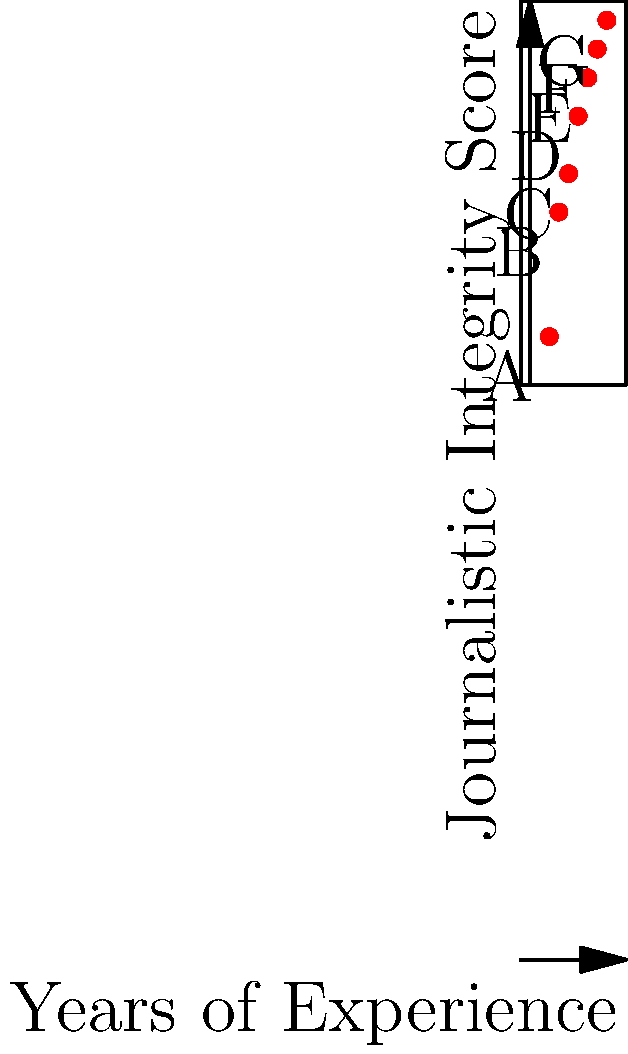The scatter plot above represents the relationship between years of experience and journalistic integrity scores for seven news outlets (A-G). Based on this data, which news outlet would you consider the most suitable candidate for implementing advanced ethical reporting practices? To determine the most suitable candidate for implementing advanced ethical reporting practices, we need to analyze the relationship between years of experience and journalistic integrity scores:

1. Identify the variables:
   - X-axis: Years of Experience
   - Y-axis: Journalistic Integrity Score

2. Analyze the trend:
   - There's a positive correlation between years of experience and integrity scores.
   - As experience increases, integrity scores generally improve.

3. Evaluate each news outlet:
   A (2, 65): Least experienced, lowest integrity score
   B (3, 78): Second least experienced, second lowest score
   C (4, 82): Third in experience, third lowest score
   D (5, 88): Middle in both experience and score
   E (6, 92): Third highest in both experience and score
   F (7, 95): Second highest in both experience and score
   G (8, 98): Most experienced, highest integrity score

4. Consider the implementation of advanced ethical practices:
   - The ideal candidate should have a high integrity score, indicating a strong ethical foundation.
   - Substantial experience is beneficial for understanding complex ethical issues.

5. Conclusion:
   News outlet G has the highest journalistic integrity score (98) and the most years of experience (8). This combination suggests they have consistently maintained high ethical standards over time and are well-positioned to implement and benefit from advanced ethical reporting practices.
Answer: News outlet G 